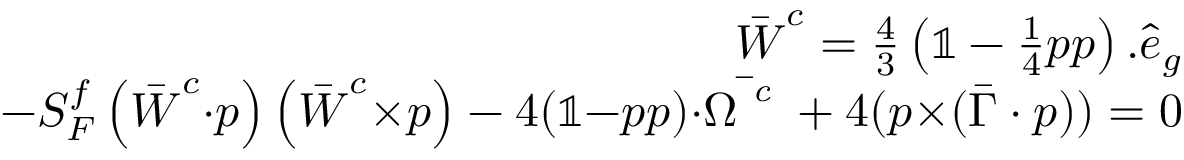Convert formula to latex. <formula><loc_0><loc_0><loc_500><loc_500>\begin{array} { r l r } & { \bar { W } ^ { c } = \frac { 4 } { 3 } \left ( \mathbb { 1 } - \frac { 1 } { 4 } p p \right ) . \hat { e } _ { g } } \\ & { - S _ { F } ^ { f } \left ( \bar { W } ^ { c } { \cdot } p \right ) \left ( \bar { W } ^ { c } { \times } p \right ) - 4 ( \mathbb { 1 } { - } p p ) { \cdot } \bar { \Omega ^ { c } } + 4 ( p { \times } ( \bar { \Gamma } \cdot p ) ) = 0 } \end{array}</formula> 